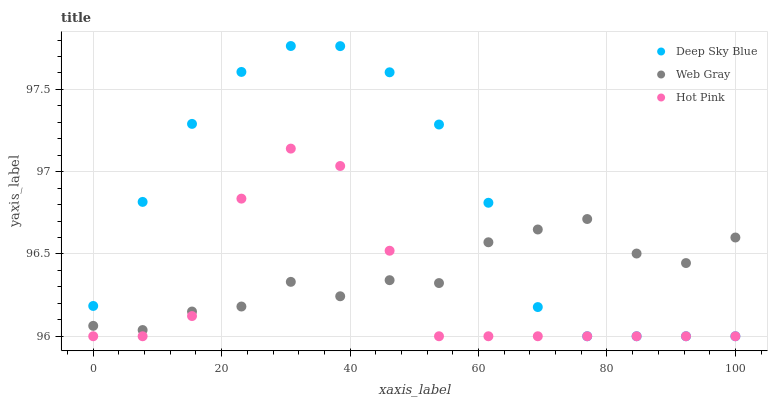Does Hot Pink have the minimum area under the curve?
Answer yes or no. Yes. Does Deep Sky Blue have the maximum area under the curve?
Answer yes or no. Yes. Does Deep Sky Blue have the minimum area under the curve?
Answer yes or no. No. Does Hot Pink have the maximum area under the curve?
Answer yes or no. No. Is Deep Sky Blue the smoothest?
Answer yes or no. Yes. Is Hot Pink the roughest?
Answer yes or no. Yes. Is Hot Pink the smoothest?
Answer yes or no. No. Is Deep Sky Blue the roughest?
Answer yes or no. No. Does Deep Sky Blue have the lowest value?
Answer yes or no. Yes. Does Deep Sky Blue have the highest value?
Answer yes or no. Yes. Does Hot Pink have the highest value?
Answer yes or no. No. Does Web Gray intersect Hot Pink?
Answer yes or no. Yes. Is Web Gray less than Hot Pink?
Answer yes or no. No. Is Web Gray greater than Hot Pink?
Answer yes or no. No. 